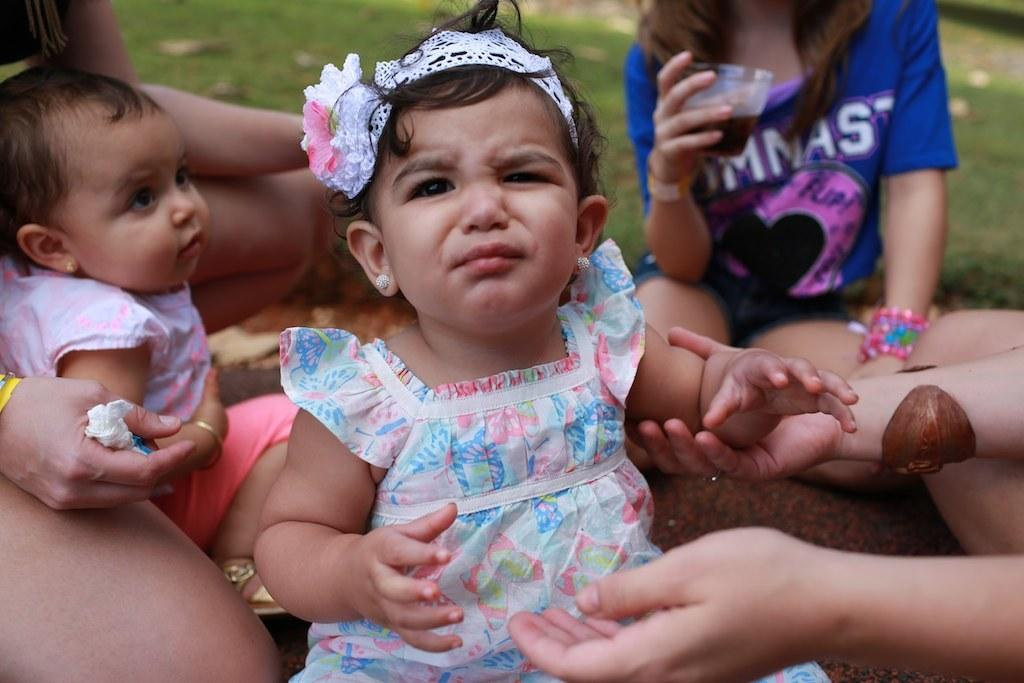Who is present in the image? There are children in the image. What are the children doing in the image? The children are sitting on the floor. What type of surface can be seen at the back side of the image? There is grass on the surface at the back side of the image. What type of library can be seen in the image? There is no library present in the image; it features children sitting on the grass. What material is the brick wall made of in the image? There is no brick wall present in the image. 